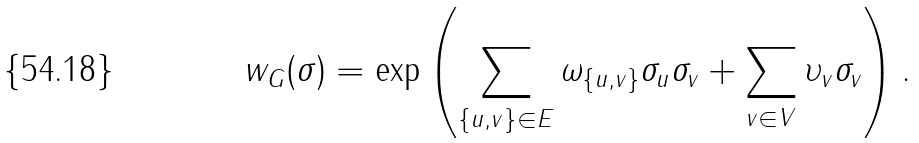Convert formula to latex. <formula><loc_0><loc_0><loc_500><loc_500>w _ { G } ( \sigma ) = \exp \left ( \sum _ { \{ u , v \} \in E } \omega _ { \{ u , v \} } \sigma _ { u } \sigma _ { v } + \sum _ { v \in V } \upsilon _ { v } \sigma _ { v } \right ) .</formula> 